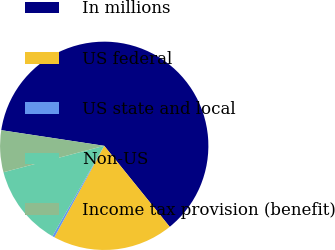<chart> <loc_0><loc_0><loc_500><loc_500><pie_chart><fcel>In millions<fcel>US federal<fcel>US state and local<fcel>Non-US<fcel>Income tax provision (benefit)<nl><fcel>61.78%<fcel>18.77%<fcel>0.34%<fcel>12.63%<fcel>6.48%<nl></chart> 